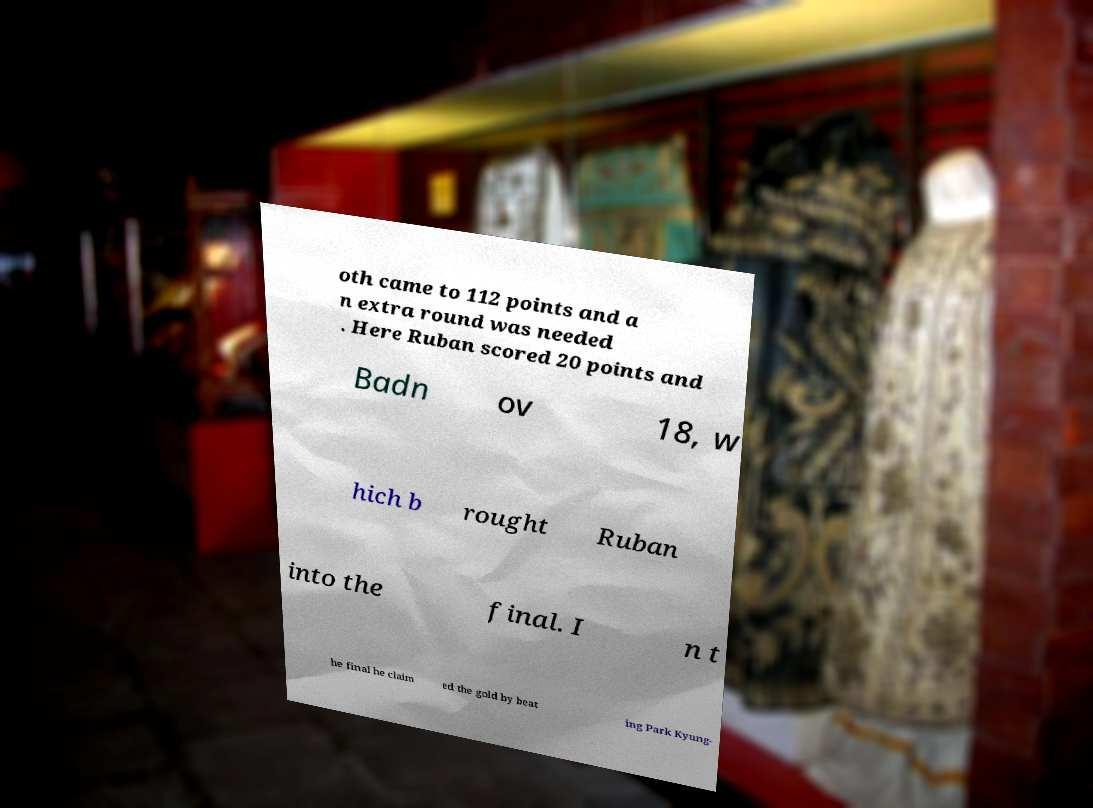Could you extract and type out the text from this image? oth came to 112 points and a n extra round was needed . Here Ruban scored 20 points and Badn ov 18, w hich b rought Ruban into the final. I n t he final he claim ed the gold by beat ing Park Kyung- 